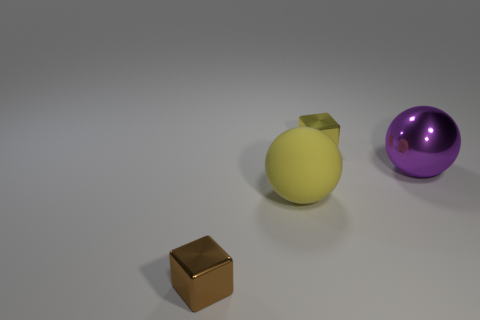Do the tiny thing that is to the right of the tiny brown object and the tiny metal object to the left of the small yellow shiny thing have the same shape?
Give a very brief answer. Yes. There is a small thing on the left side of the tiny yellow thing; what is its color?
Ensure brevity in your answer.  Brown. Are there any other yellow matte things that have the same shape as the large yellow matte object?
Your answer should be very brief. No. What is the purple ball made of?
Ensure brevity in your answer.  Metal. What is the size of the thing that is both behind the brown object and in front of the purple object?
Provide a short and direct response. Large. What number of small yellow matte balls are there?
Your answer should be very brief. 0. Are there fewer things than yellow rubber objects?
Your response must be concise. No. What material is the yellow thing that is the same size as the brown shiny thing?
Make the answer very short. Metal. What number of objects are either rubber things or small yellow metal things?
Make the answer very short. 2. What number of metallic things are in front of the large matte thing and behind the matte sphere?
Offer a terse response. 0. 